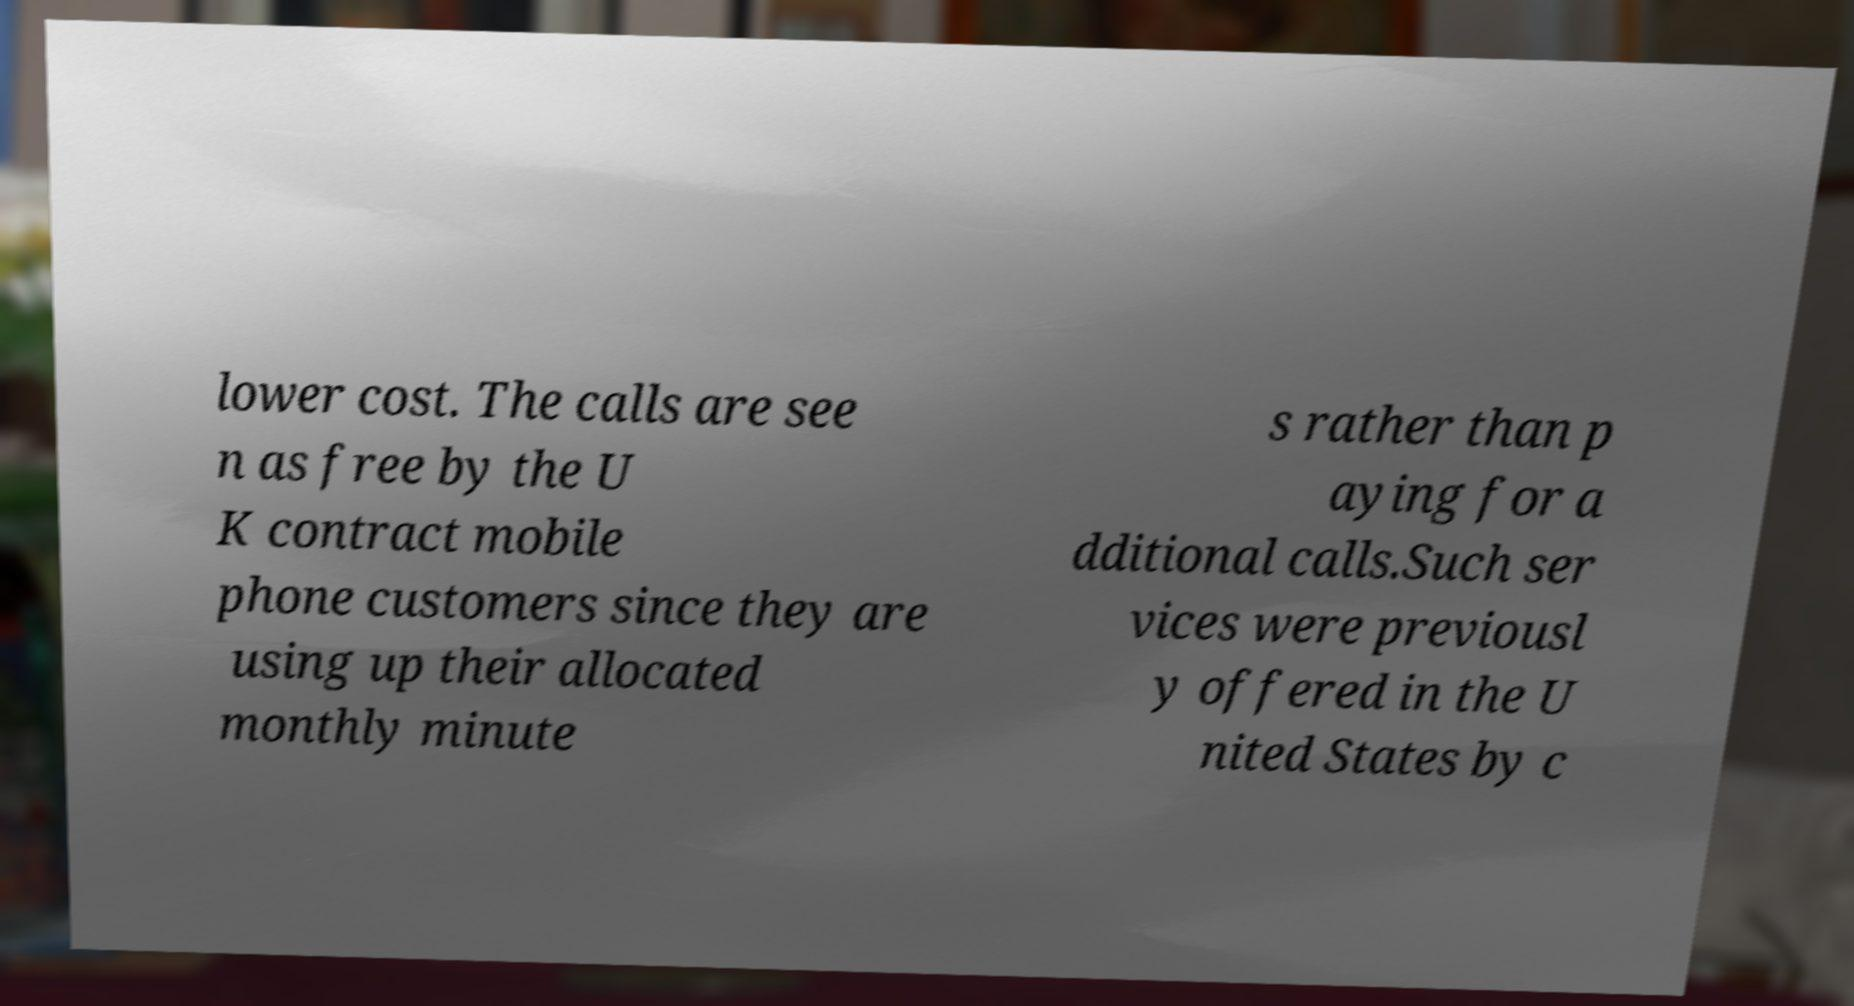There's text embedded in this image that I need extracted. Can you transcribe it verbatim? lower cost. The calls are see n as free by the U K contract mobile phone customers since they are using up their allocated monthly minute s rather than p aying for a dditional calls.Such ser vices were previousl y offered in the U nited States by c 